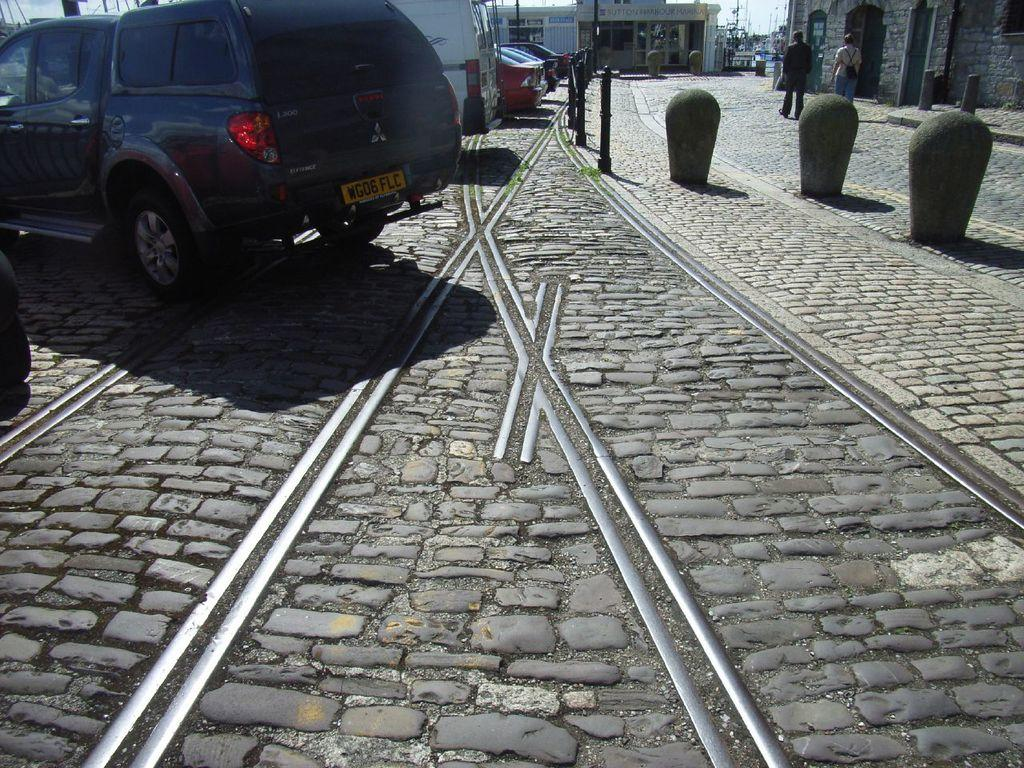What is the main feature of the image? There is a road in the image. What is happening on the road? There are cars on the road. What can be seen in the background of the image? In the background, people are walking, and there are houses. How many toads are sitting on the cars in the image? There are no toads present in the image; it features cars on a road with people walking in the background. 